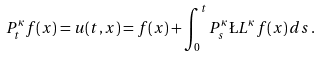<formula> <loc_0><loc_0><loc_500><loc_500>P _ { t } ^ { \kappa } f ( x ) = u ( t , x ) = f ( x ) + \int _ { 0 } ^ { t } P _ { s } ^ { \kappa } \L L ^ { \kappa } f ( x ) \, d s \, .</formula> 